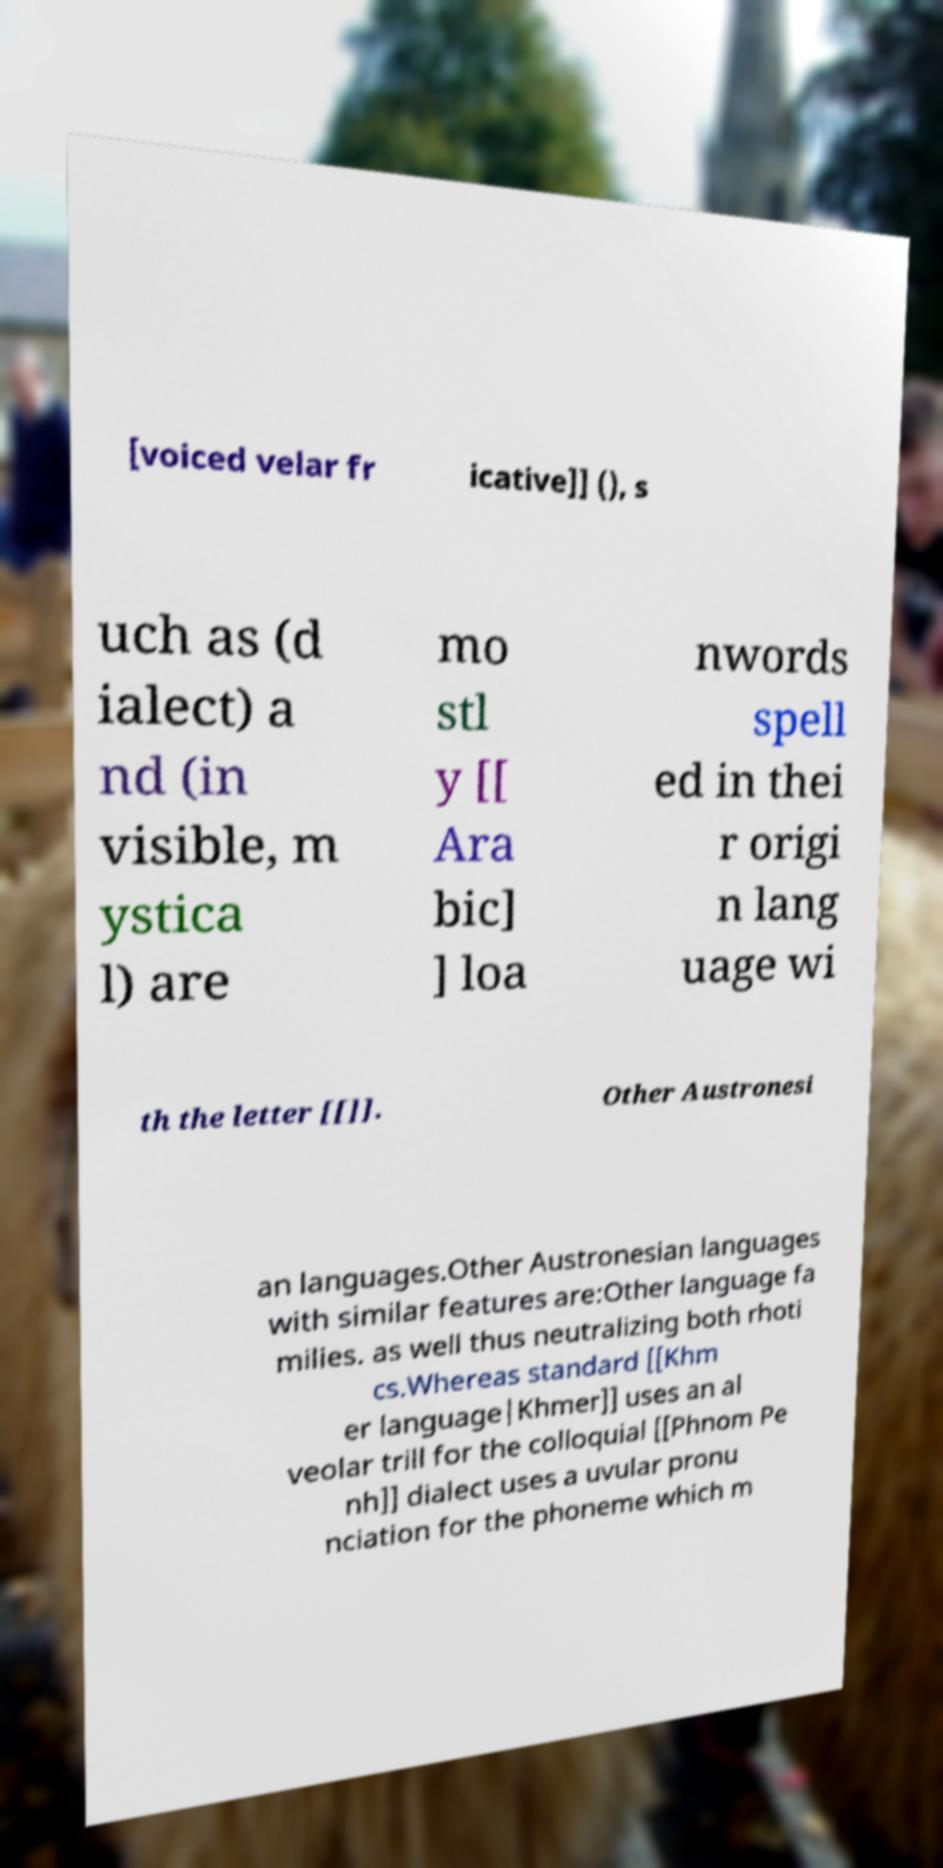Please identify and transcribe the text found in this image. [voiced velar fr icative]] (), s uch as (d ialect) a nd (in visible, m ystica l) are mo stl y [[ Ara bic] ] loa nwords spell ed in thei r origi n lang uage wi th the letter [[]]. Other Austronesi an languages.Other Austronesian languages with similar features are:Other language fa milies. as well thus neutralizing both rhoti cs.Whereas standard [[Khm er language|Khmer]] uses an al veolar trill for the colloquial [[Phnom Pe nh]] dialect uses a uvular pronu nciation for the phoneme which m 